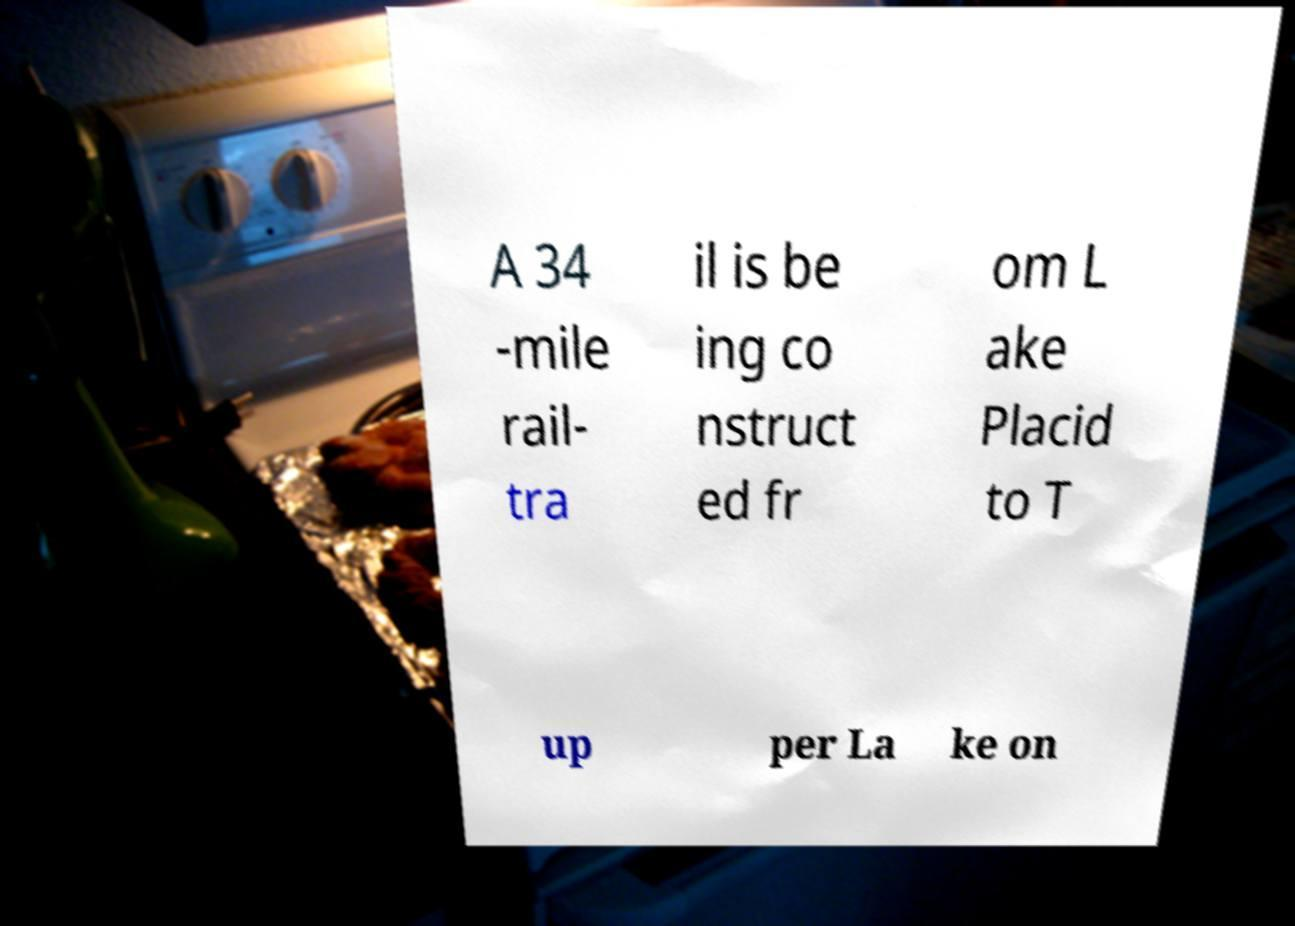Can you accurately transcribe the text from the provided image for me? A 34 -mile rail- tra il is be ing co nstruct ed fr om L ake Placid to T up per La ke on 